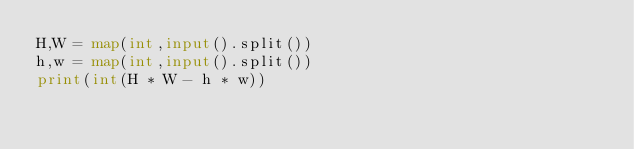Convert code to text. <code><loc_0><loc_0><loc_500><loc_500><_Python_>H,W = map(int,input().split())
h,w = map(int,input().split())
print(int(H * W - h * w))
</code> 